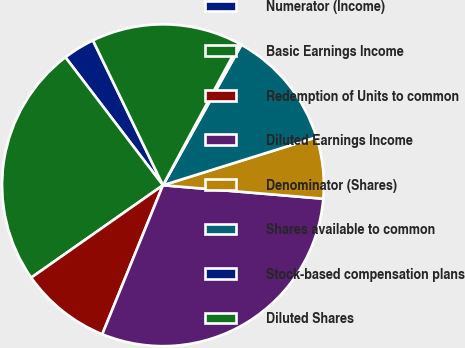<chart> <loc_0><loc_0><loc_500><loc_500><pie_chart><fcel>Numerator (Income)<fcel>Basic Earnings Income<fcel>Redemption of Units to common<fcel>Diluted Earnings Income<fcel>Denominator (Shares)<fcel>Shares available to common<fcel>Stock-based compensation plans<fcel>Diluted Shares<nl><fcel>3.2%<fcel>24.37%<fcel>9.11%<fcel>29.82%<fcel>6.16%<fcel>12.07%<fcel>0.24%<fcel>15.03%<nl></chart> 